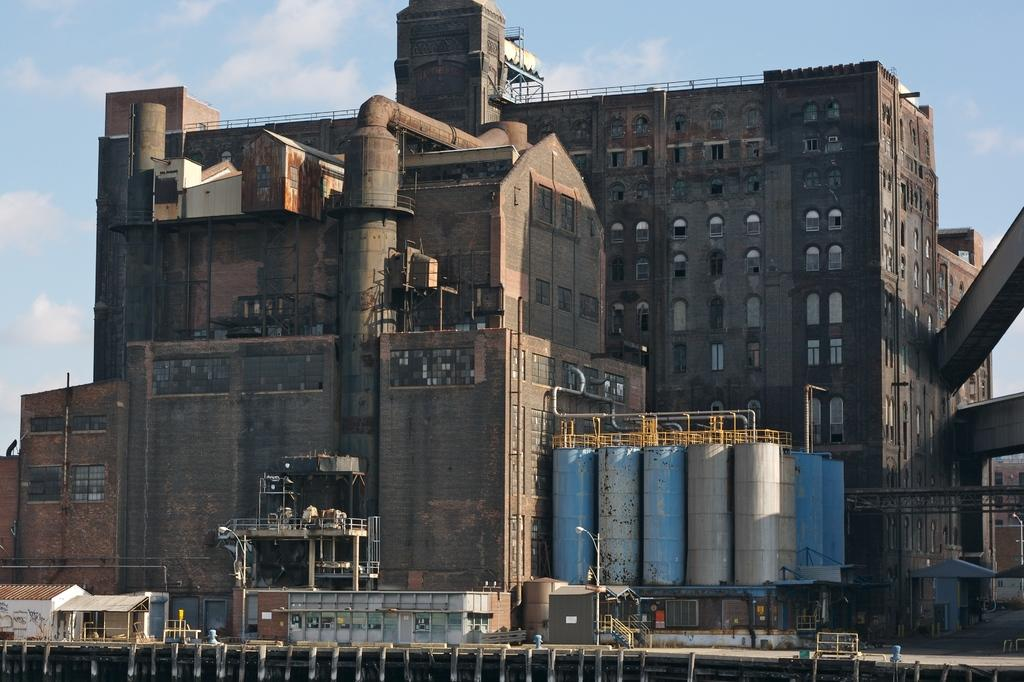What type of structures can be seen in the image? There are buildings in the image. What architectural features are visible on the buildings? There are windows in the image. What other objects can be seen in the image? There is a pipe, a fence, a street lamp, and stairs visible in the image. What are the containers used for in the image? The containers are used for storing or transporting something. What is visible at the top of the image? The sky is visible at the top of the image. How many apples are hanging from the pipe in the image? There are no apples present in the image, and therefore no such activity can be observed. 